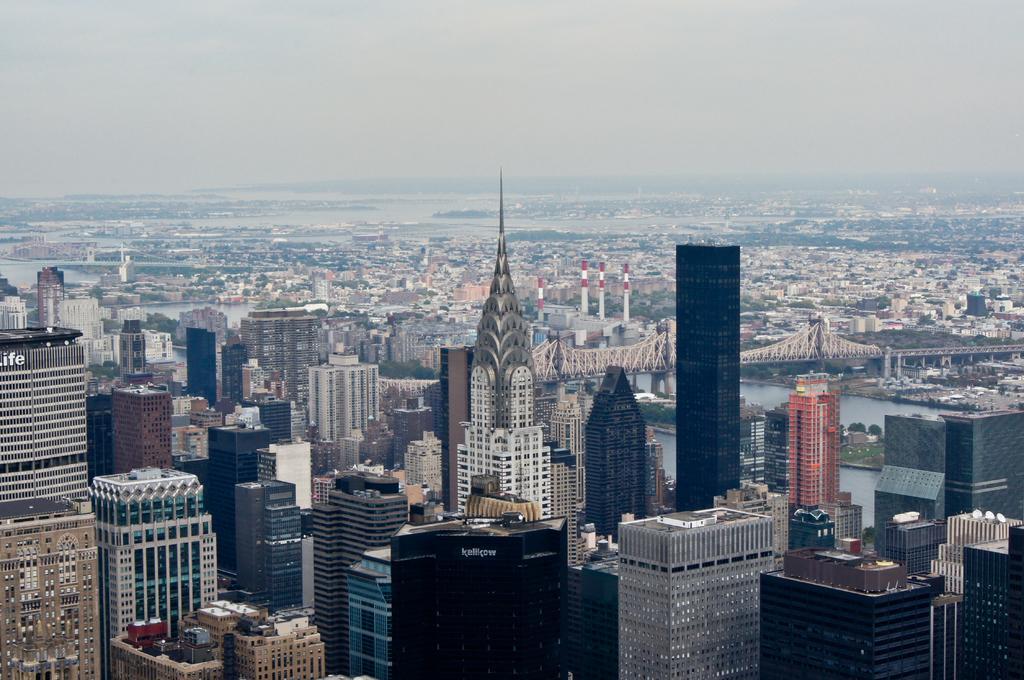Describe this image in one or two sentences. This image consists of so many buildings. There is a bridge in the middle. There is water in the middle. There is sky at the top. 